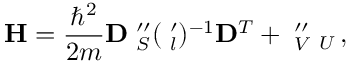Convert formula to latex. <formula><loc_0><loc_0><loc_500><loc_500>\mathbf H = \frac { \hbar { ^ } { 2 } } { 2 m } \mathbf D \mathbf \Lambda _ { S } ^ { \prime \prime } ( \mathbf \Lambda _ { l } ^ { \prime } ) ^ { - 1 } \mathbf D ^ { T } + \mathbf \Lambda _ { V } ^ { \prime \prime } \mathbf \Lambda _ { U } \, ,</formula> 